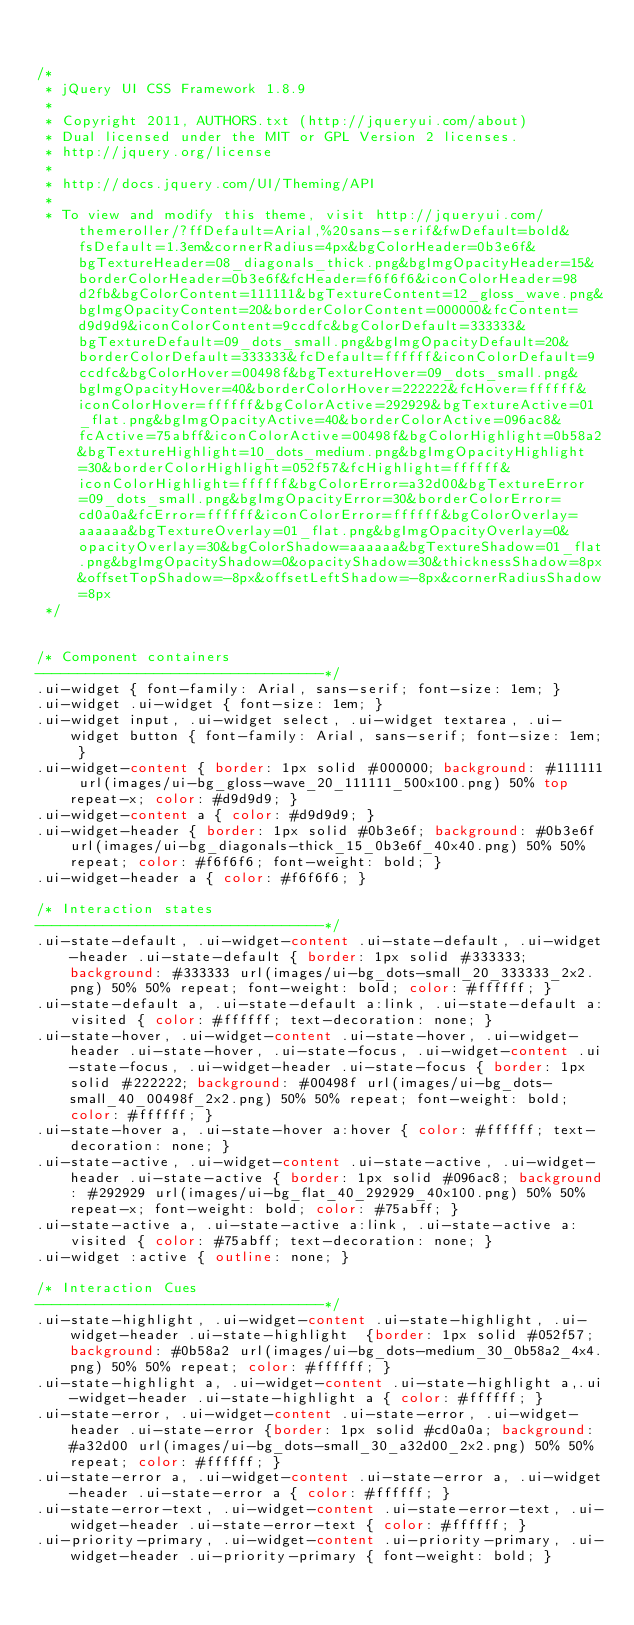<code> <loc_0><loc_0><loc_500><loc_500><_CSS_>

/*
 * jQuery UI CSS Framework 1.8.9
 *
 * Copyright 2011, AUTHORS.txt (http://jqueryui.com/about)
 * Dual licensed under the MIT or GPL Version 2 licenses.
 * http://jquery.org/license
 *
 * http://docs.jquery.com/UI/Theming/API
 *
 * To view and modify this theme, visit http://jqueryui.com/themeroller/?ffDefault=Arial,%20sans-serif&fwDefault=bold&fsDefault=1.3em&cornerRadius=4px&bgColorHeader=0b3e6f&bgTextureHeader=08_diagonals_thick.png&bgImgOpacityHeader=15&borderColorHeader=0b3e6f&fcHeader=f6f6f6&iconColorHeader=98d2fb&bgColorContent=111111&bgTextureContent=12_gloss_wave.png&bgImgOpacityContent=20&borderColorContent=000000&fcContent=d9d9d9&iconColorContent=9ccdfc&bgColorDefault=333333&bgTextureDefault=09_dots_small.png&bgImgOpacityDefault=20&borderColorDefault=333333&fcDefault=ffffff&iconColorDefault=9ccdfc&bgColorHover=00498f&bgTextureHover=09_dots_small.png&bgImgOpacityHover=40&borderColorHover=222222&fcHover=ffffff&iconColorHover=ffffff&bgColorActive=292929&bgTextureActive=01_flat.png&bgImgOpacityActive=40&borderColorActive=096ac8&fcActive=75abff&iconColorActive=00498f&bgColorHighlight=0b58a2&bgTextureHighlight=10_dots_medium.png&bgImgOpacityHighlight=30&borderColorHighlight=052f57&fcHighlight=ffffff&iconColorHighlight=ffffff&bgColorError=a32d00&bgTextureError=09_dots_small.png&bgImgOpacityError=30&borderColorError=cd0a0a&fcError=ffffff&iconColorError=ffffff&bgColorOverlay=aaaaaa&bgTextureOverlay=01_flat.png&bgImgOpacityOverlay=0&opacityOverlay=30&bgColorShadow=aaaaaa&bgTextureShadow=01_flat.png&bgImgOpacityShadow=0&opacityShadow=30&thicknessShadow=8px&offsetTopShadow=-8px&offsetLeftShadow=-8px&cornerRadiusShadow=8px
 */


/* Component containers
----------------------------------*/
.ui-widget { font-family: Arial, sans-serif; font-size: 1em; }
.ui-widget .ui-widget { font-size: 1em; }
.ui-widget input, .ui-widget select, .ui-widget textarea, .ui-widget button { font-family: Arial, sans-serif; font-size: 1em; }
.ui-widget-content { border: 1px solid #000000; background: #111111 url(images/ui-bg_gloss-wave_20_111111_500x100.png) 50% top repeat-x; color: #d9d9d9; }
.ui-widget-content a { color: #d9d9d9; }
.ui-widget-header { border: 1px solid #0b3e6f; background: #0b3e6f url(images/ui-bg_diagonals-thick_15_0b3e6f_40x40.png) 50% 50% repeat; color: #f6f6f6; font-weight: bold; }
.ui-widget-header a { color: #f6f6f6; }

/* Interaction states
----------------------------------*/
.ui-state-default, .ui-widget-content .ui-state-default, .ui-widget-header .ui-state-default { border: 1px solid #333333; background: #333333 url(images/ui-bg_dots-small_20_333333_2x2.png) 50% 50% repeat; font-weight: bold; color: #ffffff; }
.ui-state-default a, .ui-state-default a:link, .ui-state-default a:visited { color: #ffffff; text-decoration: none; }
.ui-state-hover, .ui-widget-content .ui-state-hover, .ui-widget-header .ui-state-hover, .ui-state-focus, .ui-widget-content .ui-state-focus, .ui-widget-header .ui-state-focus { border: 1px solid #222222; background: #00498f url(images/ui-bg_dots-small_40_00498f_2x2.png) 50% 50% repeat; font-weight: bold; color: #ffffff; }
.ui-state-hover a, .ui-state-hover a:hover { color: #ffffff; text-decoration: none; }
.ui-state-active, .ui-widget-content .ui-state-active, .ui-widget-header .ui-state-active { border: 1px solid #096ac8; background: #292929 url(images/ui-bg_flat_40_292929_40x100.png) 50% 50% repeat-x; font-weight: bold; color: #75abff; }
.ui-state-active a, .ui-state-active a:link, .ui-state-active a:visited { color: #75abff; text-decoration: none; }
.ui-widget :active { outline: none; }

/* Interaction Cues
----------------------------------*/
.ui-state-highlight, .ui-widget-content .ui-state-highlight, .ui-widget-header .ui-state-highlight  {border: 1px solid #052f57; background: #0b58a2 url(images/ui-bg_dots-medium_30_0b58a2_4x4.png) 50% 50% repeat; color: #ffffff; }
.ui-state-highlight a, .ui-widget-content .ui-state-highlight a,.ui-widget-header .ui-state-highlight a { color: #ffffff; }
.ui-state-error, .ui-widget-content .ui-state-error, .ui-widget-header .ui-state-error {border: 1px solid #cd0a0a; background: #a32d00 url(images/ui-bg_dots-small_30_a32d00_2x2.png) 50% 50% repeat; color: #ffffff; }
.ui-state-error a, .ui-widget-content .ui-state-error a, .ui-widget-header .ui-state-error a { color: #ffffff; }
.ui-state-error-text, .ui-widget-content .ui-state-error-text, .ui-widget-header .ui-state-error-text { color: #ffffff; }
.ui-priority-primary, .ui-widget-content .ui-priority-primary, .ui-widget-header .ui-priority-primary { font-weight: bold; }</code> 